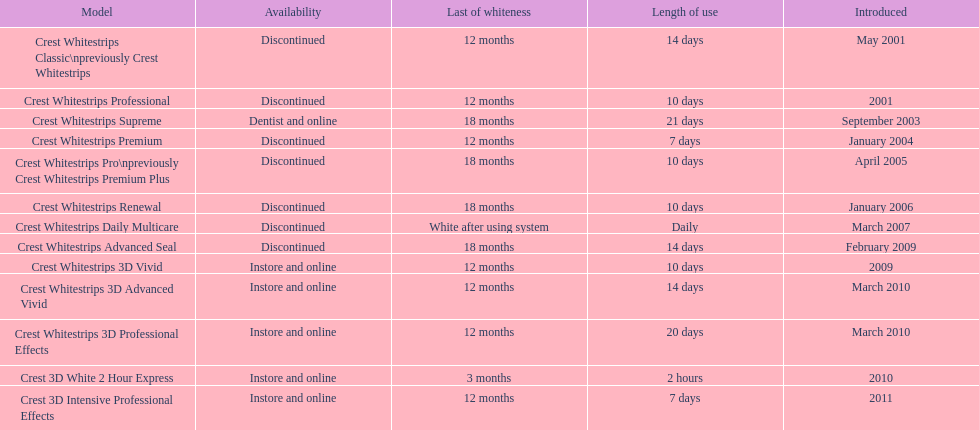Which discontinued product was introduced the same year as crest whitestrips 3d vivid? Crest Whitestrips Advanced Seal. Can you give me this table as a dict? {'header': ['Model', 'Availability', 'Last of whiteness', 'Length of use', 'Introduced'], 'rows': [['Crest Whitestrips Classic\\npreviously Crest Whitestrips', 'Discontinued', '12 months', '14 days', 'May 2001'], ['Crest Whitestrips Professional', 'Discontinued', '12 months', '10 days', '2001'], ['Crest Whitestrips Supreme', 'Dentist and online', '18 months', '21 days', 'September 2003'], ['Crest Whitestrips Premium', 'Discontinued', '12 months', '7 days', 'January 2004'], ['Crest Whitestrips Pro\\npreviously Crest Whitestrips Premium Plus', 'Discontinued', '18 months', '10 days', 'April 2005'], ['Crest Whitestrips Renewal', 'Discontinued', '18 months', '10 days', 'January 2006'], ['Crest Whitestrips Daily Multicare', 'Discontinued', 'White after using system', 'Daily', 'March 2007'], ['Crest Whitestrips Advanced Seal', 'Discontinued', '18 months', '14 days', 'February 2009'], ['Crest Whitestrips 3D Vivid', 'Instore and online', '12 months', '10 days', '2009'], ['Crest Whitestrips 3D Advanced Vivid', 'Instore and online', '12 months', '14 days', 'March 2010'], ['Crest Whitestrips 3D Professional Effects', 'Instore and online', '12 months', '20 days', 'March 2010'], ['Crest 3D White 2 Hour Express', 'Instore and online', '3 months', '2 hours', '2010'], ['Crest 3D Intensive Professional Effects', 'Instore and online', '12 months', '7 days', '2011']]} 